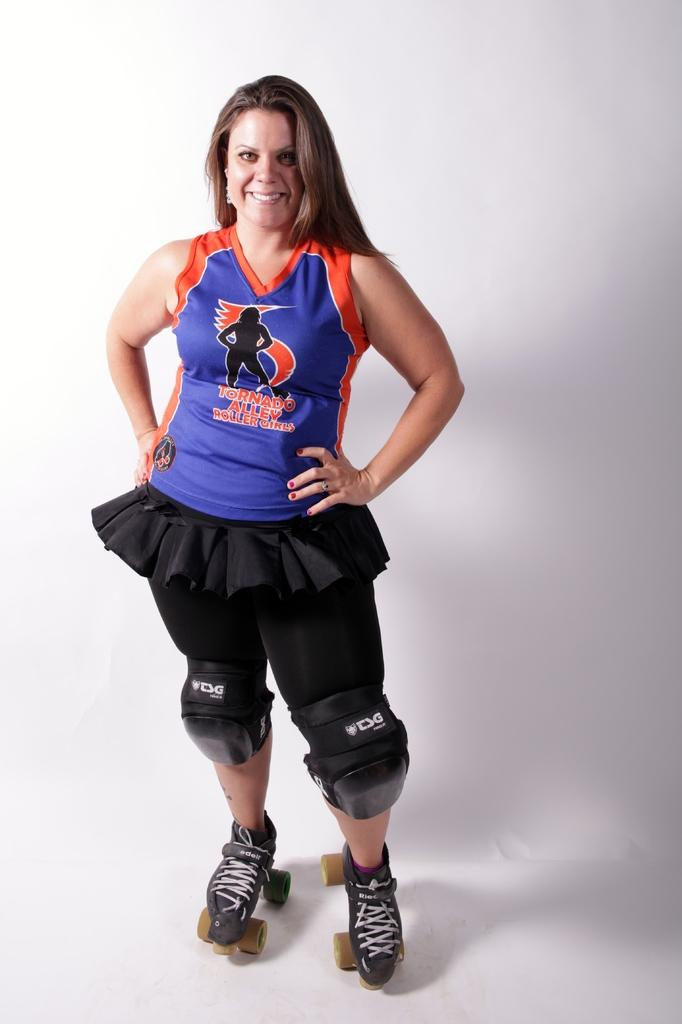<image>
Summarize the visual content of the image. A girl in a blue and orange shirt that says Tornado Alley is wearing roller skates. 